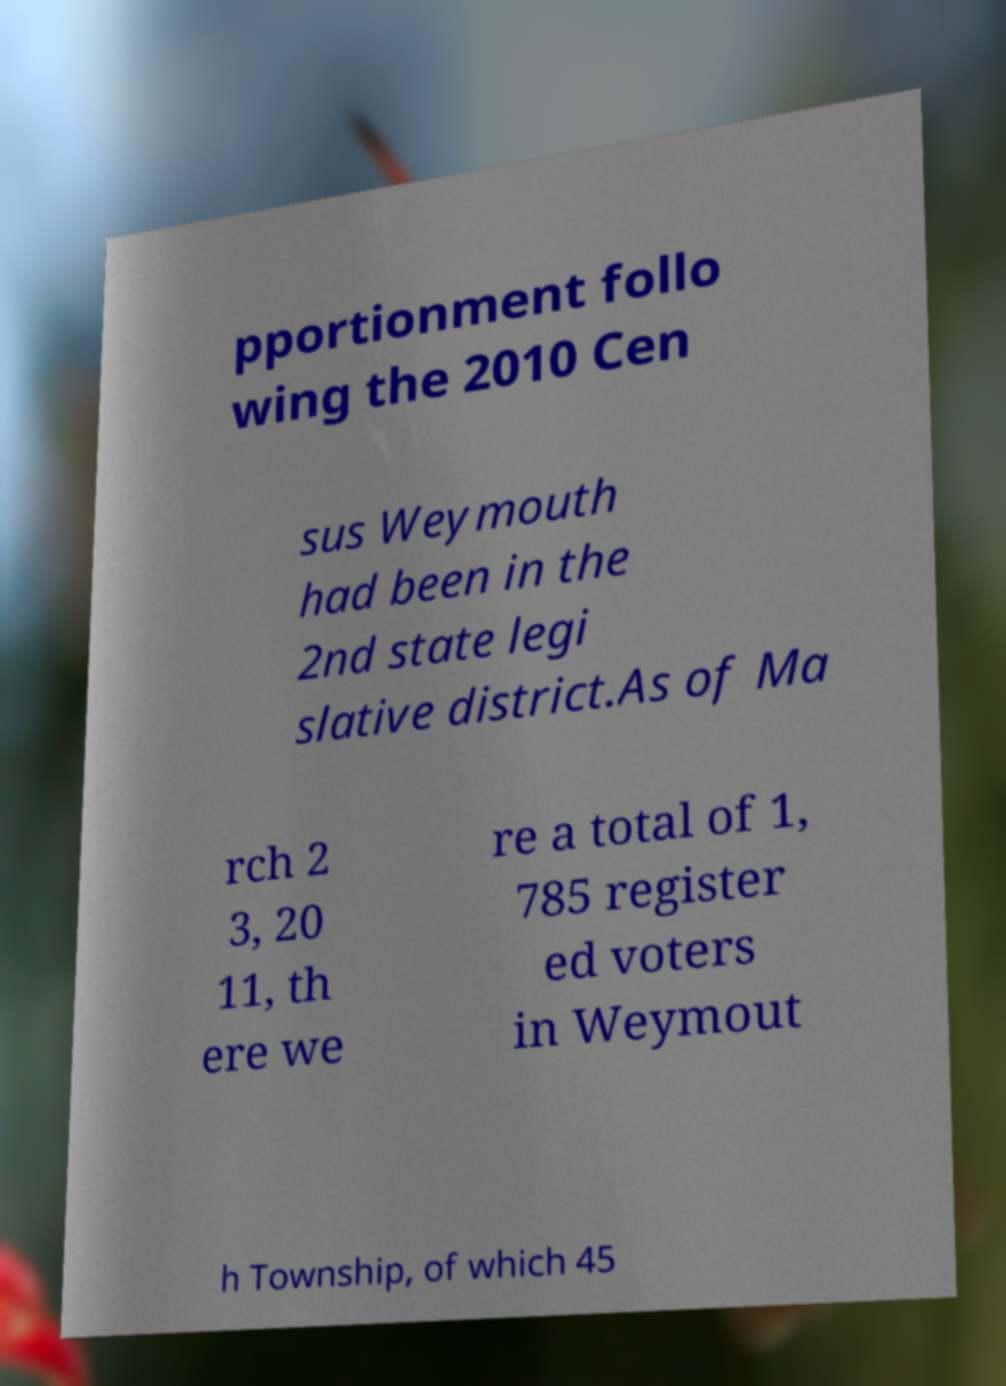Could you assist in decoding the text presented in this image and type it out clearly? pportionment follo wing the 2010 Cen sus Weymouth had been in the 2nd state legi slative district.As of Ma rch 2 3, 20 11, th ere we re a total of 1, 785 register ed voters in Weymout h Township, of which 45 